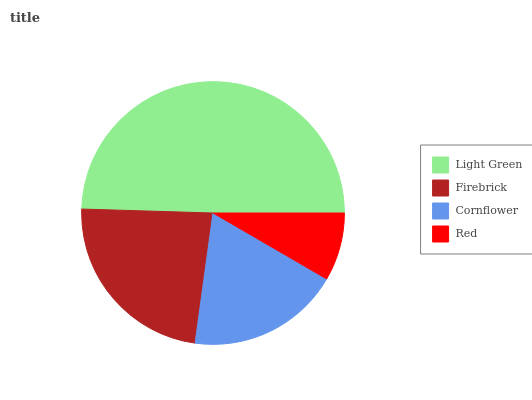Is Red the minimum?
Answer yes or no. Yes. Is Light Green the maximum?
Answer yes or no. Yes. Is Firebrick the minimum?
Answer yes or no. No. Is Firebrick the maximum?
Answer yes or no. No. Is Light Green greater than Firebrick?
Answer yes or no. Yes. Is Firebrick less than Light Green?
Answer yes or no. Yes. Is Firebrick greater than Light Green?
Answer yes or no. No. Is Light Green less than Firebrick?
Answer yes or no. No. Is Firebrick the high median?
Answer yes or no. Yes. Is Cornflower the low median?
Answer yes or no. Yes. Is Cornflower the high median?
Answer yes or no. No. Is Light Green the low median?
Answer yes or no. No. 